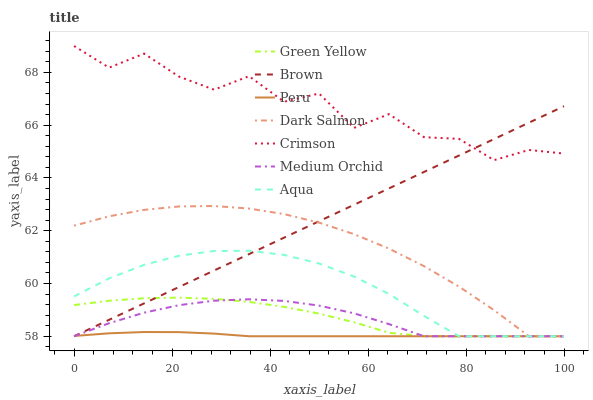Does Peru have the minimum area under the curve?
Answer yes or no. Yes. Does Crimson have the maximum area under the curve?
Answer yes or no. Yes. Does Medium Orchid have the minimum area under the curve?
Answer yes or no. No. Does Medium Orchid have the maximum area under the curve?
Answer yes or no. No. Is Brown the smoothest?
Answer yes or no. Yes. Is Crimson the roughest?
Answer yes or no. Yes. Is Medium Orchid the smoothest?
Answer yes or no. No. Is Medium Orchid the roughest?
Answer yes or no. No. Does Brown have the lowest value?
Answer yes or no. Yes. Does Crimson have the lowest value?
Answer yes or no. No. Does Crimson have the highest value?
Answer yes or no. Yes. Does Medium Orchid have the highest value?
Answer yes or no. No. Is Peru less than Crimson?
Answer yes or no. Yes. Is Crimson greater than Peru?
Answer yes or no. Yes. Does Dark Salmon intersect Peru?
Answer yes or no. Yes. Is Dark Salmon less than Peru?
Answer yes or no. No. Is Dark Salmon greater than Peru?
Answer yes or no. No. Does Peru intersect Crimson?
Answer yes or no. No. 